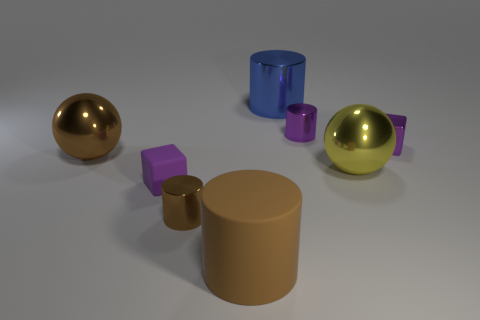Subtract 1 cylinders. How many cylinders are left? 3 Add 2 red cylinders. How many objects exist? 10 Subtract all cyan cylinders. Subtract all gray spheres. How many cylinders are left? 4 Subtract all balls. How many objects are left? 6 Add 7 purple metal blocks. How many purple metal blocks exist? 8 Subtract 0 red cylinders. How many objects are left? 8 Subtract all big blue blocks. Subtract all big metallic things. How many objects are left? 5 Add 5 tiny purple metal objects. How many tiny purple metal objects are left? 7 